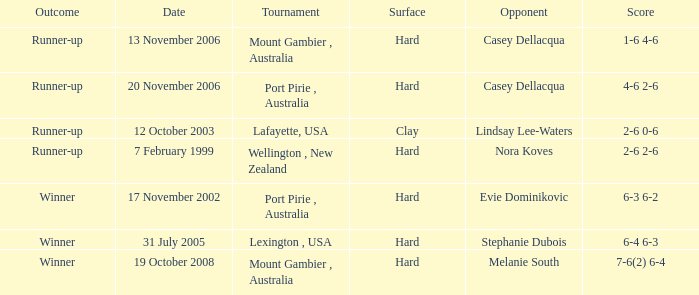Which Score has an Opponent of melanie south? 7-6(2) 6-4. 